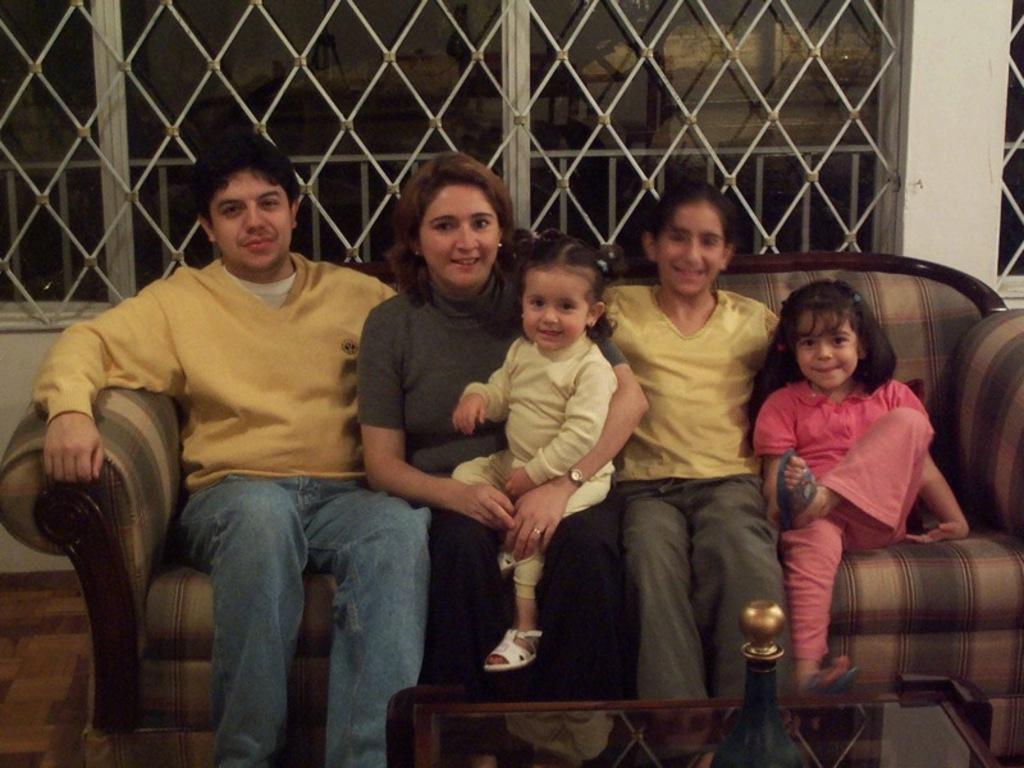Please provide a concise description of this image. In the center of the image some persons are sitting on the couch. At the bottom of the image there is a table. On the table an object is there. In the background of the image we can see windows, grills, wall are there. On the left side of the image floor is there. 